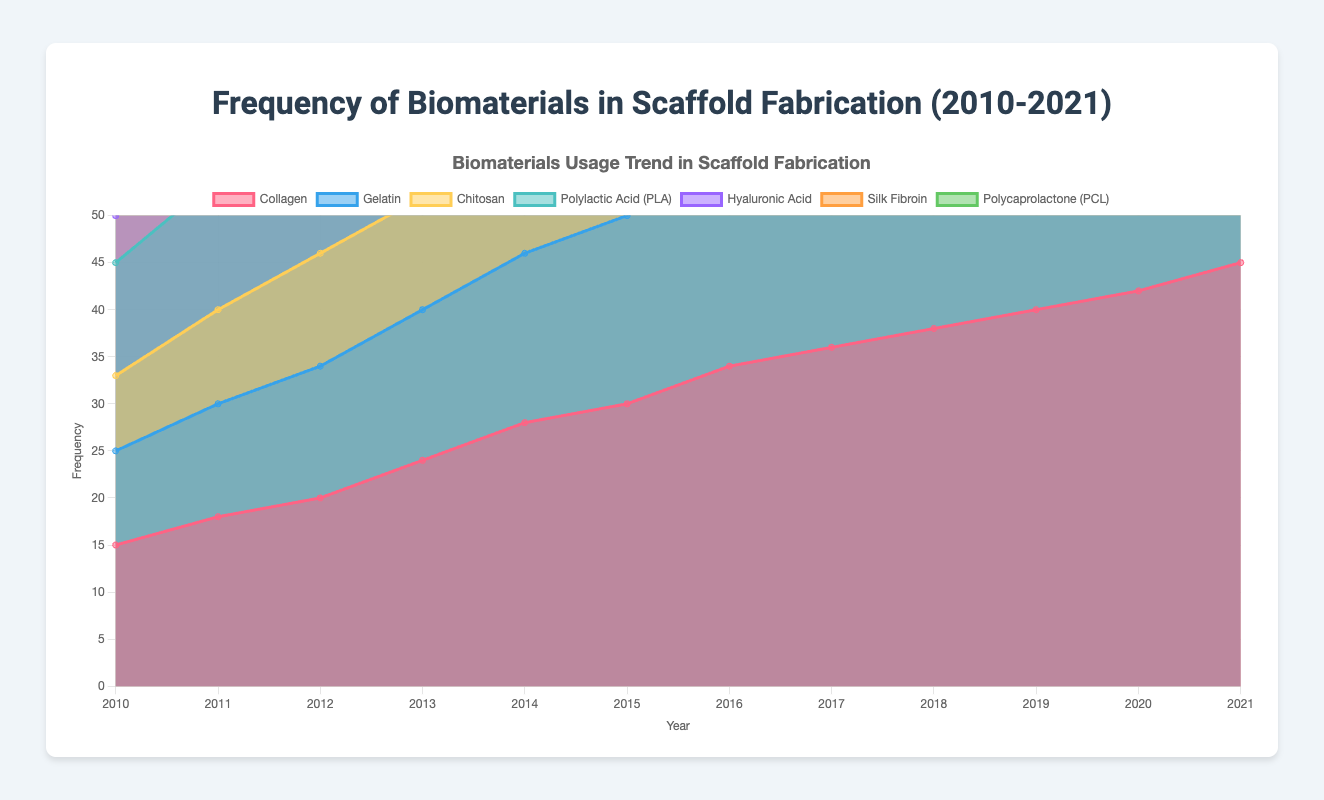How many different biomaterials are shown in the figure? The figure shows seven different biomaterials, each represented by a different colored area.
Answer: 7 Which biomaterial had the highest frequency in 2021? In 2021, the biomaterial with the highest frequency can be identified by looking at the tallest area in the chart for that year. This would be Collagen.
Answer: Collagen Has the usage frequency of Hyaluronic Acid ever decreased over the years? To determine this, we examine the trend line for Hyaluronic Acid over the years. We can observe that the frequency consistently increased from 5 in 2010 to 26 in 2021.
Answer: No Between 2014 and 2017, which biomaterial showed the fastest growth in frequency? We need to calculate the difference in frequencies of each biomaterial between 2014 and 2017. The biggest increase is observed in the frequency of Gelatin, which grew from 18 to 26 (an increase of 8).
Answer: Gelatin What is the difference in frequency between Silk Fibroin and Polycaprolactone (PCL) in 2015? In 2015, the frequency of Silk Fibroin is 16, and Polycaprolactone (PCL) is 19. Subtracting the two gives the difference: 19 - 16 = 3.
Answer: 3 Which two biomaterials had the closest frequency values in 2018? In 2018, we compare the values of all biomaterials and find that Silk Fibroin and Polycaprolactone (PCL) had frequencies of 22 and 26, which are the closest among the pairs.
Answer: Polycaprolactone (PCL) and Silk Fibroin Did any biomaterial surpass Polylactic Acid (PLA) in frequency at any point? By examining each year's data, we see that no other biomaterial had a higher frequency than PLA in any of the years listed.
Answer: No Among all the biomaterials, which one shows the most steady trend over the years? A steady trend means the values increase linearly or at a consistent rate with no sharp fluctuations. Collagen's trend appears to be the most consistent and steady.
Answer: Collagen 